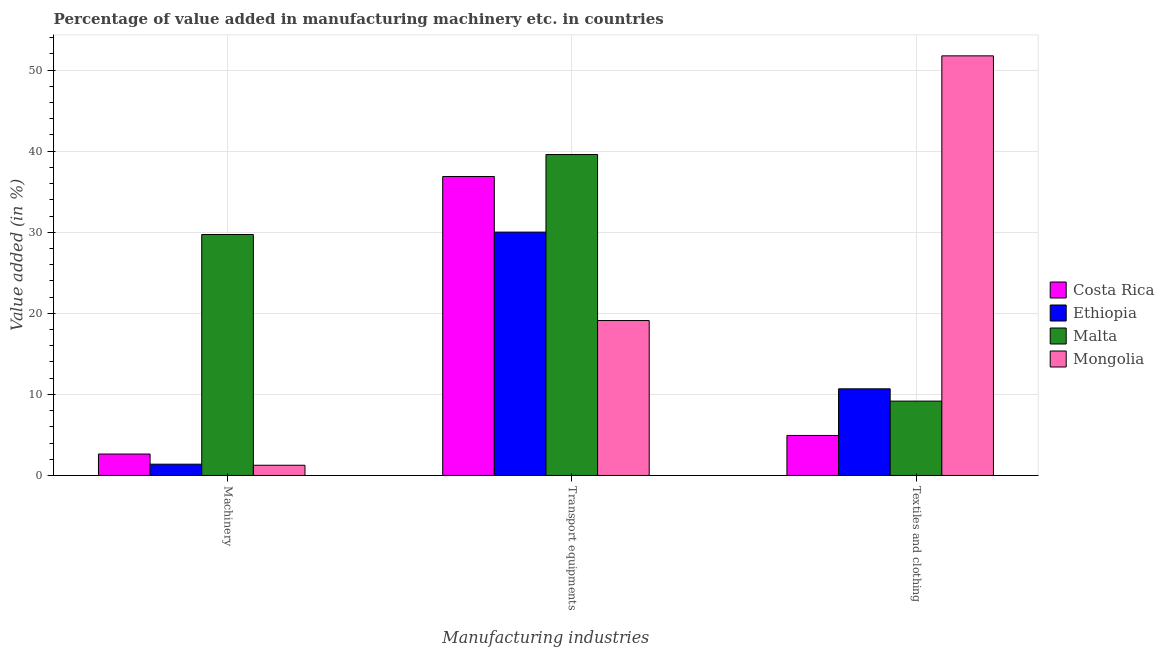Are the number of bars per tick equal to the number of legend labels?
Give a very brief answer. Yes. How many bars are there on the 1st tick from the left?
Your answer should be compact. 4. What is the label of the 3rd group of bars from the left?
Ensure brevity in your answer.  Textiles and clothing. What is the value added in manufacturing transport equipments in Costa Rica?
Your response must be concise. 36.88. Across all countries, what is the maximum value added in manufacturing textile and clothing?
Ensure brevity in your answer.  51.76. Across all countries, what is the minimum value added in manufacturing textile and clothing?
Your answer should be compact. 4.93. In which country was the value added in manufacturing textile and clothing maximum?
Your answer should be compact. Mongolia. In which country was the value added in manufacturing textile and clothing minimum?
Your answer should be very brief. Costa Rica. What is the total value added in manufacturing machinery in the graph?
Ensure brevity in your answer.  35.01. What is the difference between the value added in manufacturing machinery in Mongolia and that in Costa Rica?
Provide a short and direct response. -1.38. What is the difference between the value added in manufacturing textile and clothing in Costa Rica and the value added in manufacturing transport equipments in Malta?
Keep it short and to the point. -34.66. What is the average value added in manufacturing textile and clothing per country?
Ensure brevity in your answer.  19.14. What is the difference between the value added in manufacturing machinery and value added in manufacturing textile and clothing in Malta?
Provide a succinct answer. 20.55. In how many countries, is the value added in manufacturing textile and clothing greater than 50 %?
Give a very brief answer. 1. What is the ratio of the value added in manufacturing transport equipments in Malta to that in Costa Rica?
Your response must be concise. 1.07. Is the difference between the value added in manufacturing machinery in Costa Rica and Mongolia greater than the difference between the value added in manufacturing textile and clothing in Costa Rica and Mongolia?
Give a very brief answer. Yes. What is the difference between the highest and the second highest value added in manufacturing transport equipments?
Offer a very short reply. 2.71. What is the difference between the highest and the lowest value added in manufacturing machinery?
Ensure brevity in your answer.  28.47. In how many countries, is the value added in manufacturing machinery greater than the average value added in manufacturing machinery taken over all countries?
Your answer should be very brief. 1. What does the 4th bar from the right in Textiles and clothing represents?
Provide a short and direct response. Costa Rica. Is it the case that in every country, the sum of the value added in manufacturing machinery and value added in manufacturing transport equipments is greater than the value added in manufacturing textile and clothing?
Your answer should be compact. No. How many countries are there in the graph?
Your answer should be very brief. 4. What is the difference between two consecutive major ticks on the Y-axis?
Make the answer very short. 10. Are the values on the major ticks of Y-axis written in scientific E-notation?
Offer a very short reply. No. Does the graph contain any zero values?
Your answer should be compact. No. Where does the legend appear in the graph?
Provide a succinct answer. Center right. How are the legend labels stacked?
Offer a very short reply. Vertical. What is the title of the graph?
Give a very brief answer. Percentage of value added in manufacturing machinery etc. in countries. What is the label or title of the X-axis?
Your answer should be very brief. Manufacturing industries. What is the label or title of the Y-axis?
Provide a succinct answer. Value added (in %). What is the Value added (in %) in Costa Rica in Machinery?
Ensure brevity in your answer.  2.64. What is the Value added (in %) in Ethiopia in Machinery?
Your answer should be very brief. 1.39. What is the Value added (in %) of Malta in Machinery?
Offer a terse response. 29.72. What is the Value added (in %) in Mongolia in Machinery?
Make the answer very short. 1.26. What is the Value added (in %) of Costa Rica in Transport equipments?
Make the answer very short. 36.88. What is the Value added (in %) of Ethiopia in Transport equipments?
Ensure brevity in your answer.  30.02. What is the Value added (in %) of Malta in Transport equipments?
Make the answer very short. 39.59. What is the Value added (in %) in Mongolia in Transport equipments?
Ensure brevity in your answer.  19.11. What is the Value added (in %) of Costa Rica in Textiles and clothing?
Make the answer very short. 4.93. What is the Value added (in %) in Ethiopia in Textiles and clothing?
Offer a terse response. 10.69. What is the Value added (in %) in Malta in Textiles and clothing?
Your answer should be compact. 9.17. What is the Value added (in %) of Mongolia in Textiles and clothing?
Give a very brief answer. 51.76. Across all Manufacturing industries, what is the maximum Value added (in %) in Costa Rica?
Keep it short and to the point. 36.88. Across all Manufacturing industries, what is the maximum Value added (in %) of Ethiopia?
Your answer should be very brief. 30.02. Across all Manufacturing industries, what is the maximum Value added (in %) of Malta?
Provide a succinct answer. 39.59. Across all Manufacturing industries, what is the maximum Value added (in %) of Mongolia?
Keep it short and to the point. 51.76. Across all Manufacturing industries, what is the minimum Value added (in %) in Costa Rica?
Give a very brief answer. 2.64. Across all Manufacturing industries, what is the minimum Value added (in %) in Ethiopia?
Offer a terse response. 1.39. Across all Manufacturing industries, what is the minimum Value added (in %) in Malta?
Provide a succinct answer. 9.17. Across all Manufacturing industries, what is the minimum Value added (in %) in Mongolia?
Keep it short and to the point. 1.26. What is the total Value added (in %) in Costa Rica in the graph?
Give a very brief answer. 44.46. What is the total Value added (in %) in Ethiopia in the graph?
Give a very brief answer. 42.1. What is the total Value added (in %) in Malta in the graph?
Your response must be concise. 78.49. What is the total Value added (in %) in Mongolia in the graph?
Offer a terse response. 72.13. What is the difference between the Value added (in %) in Costa Rica in Machinery and that in Transport equipments?
Give a very brief answer. -34.24. What is the difference between the Value added (in %) of Ethiopia in Machinery and that in Transport equipments?
Ensure brevity in your answer.  -28.63. What is the difference between the Value added (in %) in Malta in Machinery and that in Transport equipments?
Make the answer very short. -9.87. What is the difference between the Value added (in %) of Mongolia in Machinery and that in Transport equipments?
Your response must be concise. -17.85. What is the difference between the Value added (in %) of Costa Rica in Machinery and that in Textiles and clothing?
Your answer should be compact. -2.29. What is the difference between the Value added (in %) in Ethiopia in Machinery and that in Textiles and clothing?
Your answer should be very brief. -9.3. What is the difference between the Value added (in %) of Malta in Machinery and that in Textiles and clothing?
Offer a terse response. 20.55. What is the difference between the Value added (in %) in Mongolia in Machinery and that in Textiles and clothing?
Your answer should be compact. -50.51. What is the difference between the Value added (in %) in Costa Rica in Transport equipments and that in Textiles and clothing?
Ensure brevity in your answer.  31.95. What is the difference between the Value added (in %) of Ethiopia in Transport equipments and that in Textiles and clothing?
Offer a very short reply. 19.33. What is the difference between the Value added (in %) in Malta in Transport equipments and that in Textiles and clothing?
Your answer should be compact. 30.42. What is the difference between the Value added (in %) of Mongolia in Transport equipments and that in Textiles and clothing?
Provide a short and direct response. -32.66. What is the difference between the Value added (in %) of Costa Rica in Machinery and the Value added (in %) of Ethiopia in Transport equipments?
Provide a succinct answer. -27.38. What is the difference between the Value added (in %) of Costa Rica in Machinery and the Value added (in %) of Malta in Transport equipments?
Your answer should be very brief. -36.95. What is the difference between the Value added (in %) in Costa Rica in Machinery and the Value added (in %) in Mongolia in Transport equipments?
Your answer should be very brief. -16.47. What is the difference between the Value added (in %) in Ethiopia in Machinery and the Value added (in %) in Malta in Transport equipments?
Offer a very short reply. -38.2. What is the difference between the Value added (in %) in Ethiopia in Machinery and the Value added (in %) in Mongolia in Transport equipments?
Provide a succinct answer. -17.72. What is the difference between the Value added (in %) in Malta in Machinery and the Value added (in %) in Mongolia in Transport equipments?
Keep it short and to the point. 10.62. What is the difference between the Value added (in %) in Costa Rica in Machinery and the Value added (in %) in Ethiopia in Textiles and clothing?
Your response must be concise. -8.05. What is the difference between the Value added (in %) in Costa Rica in Machinery and the Value added (in %) in Malta in Textiles and clothing?
Your response must be concise. -6.53. What is the difference between the Value added (in %) in Costa Rica in Machinery and the Value added (in %) in Mongolia in Textiles and clothing?
Make the answer very short. -49.12. What is the difference between the Value added (in %) in Ethiopia in Machinery and the Value added (in %) in Malta in Textiles and clothing?
Your response must be concise. -7.78. What is the difference between the Value added (in %) of Ethiopia in Machinery and the Value added (in %) of Mongolia in Textiles and clothing?
Provide a succinct answer. -50.37. What is the difference between the Value added (in %) in Malta in Machinery and the Value added (in %) in Mongolia in Textiles and clothing?
Your answer should be compact. -22.04. What is the difference between the Value added (in %) in Costa Rica in Transport equipments and the Value added (in %) in Ethiopia in Textiles and clothing?
Give a very brief answer. 26.2. What is the difference between the Value added (in %) in Costa Rica in Transport equipments and the Value added (in %) in Malta in Textiles and clothing?
Your answer should be very brief. 27.71. What is the difference between the Value added (in %) of Costa Rica in Transport equipments and the Value added (in %) of Mongolia in Textiles and clothing?
Provide a short and direct response. -14.88. What is the difference between the Value added (in %) in Ethiopia in Transport equipments and the Value added (in %) in Malta in Textiles and clothing?
Your answer should be compact. 20.85. What is the difference between the Value added (in %) of Ethiopia in Transport equipments and the Value added (in %) of Mongolia in Textiles and clothing?
Your response must be concise. -21.74. What is the difference between the Value added (in %) of Malta in Transport equipments and the Value added (in %) of Mongolia in Textiles and clothing?
Offer a very short reply. -12.17. What is the average Value added (in %) of Costa Rica per Manufacturing industries?
Give a very brief answer. 14.82. What is the average Value added (in %) in Ethiopia per Manufacturing industries?
Your answer should be compact. 14.03. What is the average Value added (in %) of Malta per Manufacturing industries?
Your answer should be very brief. 26.16. What is the average Value added (in %) of Mongolia per Manufacturing industries?
Keep it short and to the point. 24.04. What is the difference between the Value added (in %) of Costa Rica and Value added (in %) of Ethiopia in Machinery?
Make the answer very short. 1.25. What is the difference between the Value added (in %) of Costa Rica and Value added (in %) of Malta in Machinery?
Offer a very short reply. -27.08. What is the difference between the Value added (in %) in Costa Rica and Value added (in %) in Mongolia in Machinery?
Provide a short and direct response. 1.38. What is the difference between the Value added (in %) of Ethiopia and Value added (in %) of Malta in Machinery?
Provide a short and direct response. -28.33. What is the difference between the Value added (in %) of Ethiopia and Value added (in %) of Mongolia in Machinery?
Provide a succinct answer. 0.13. What is the difference between the Value added (in %) of Malta and Value added (in %) of Mongolia in Machinery?
Offer a very short reply. 28.47. What is the difference between the Value added (in %) of Costa Rica and Value added (in %) of Ethiopia in Transport equipments?
Give a very brief answer. 6.86. What is the difference between the Value added (in %) of Costa Rica and Value added (in %) of Malta in Transport equipments?
Provide a short and direct response. -2.71. What is the difference between the Value added (in %) in Costa Rica and Value added (in %) in Mongolia in Transport equipments?
Provide a succinct answer. 17.77. What is the difference between the Value added (in %) of Ethiopia and Value added (in %) of Malta in Transport equipments?
Offer a very short reply. -9.57. What is the difference between the Value added (in %) in Ethiopia and Value added (in %) in Mongolia in Transport equipments?
Ensure brevity in your answer.  10.91. What is the difference between the Value added (in %) in Malta and Value added (in %) in Mongolia in Transport equipments?
Ensure brevity in your answer.  20.48. What is the difference between the Value added (in %) of Costa Rica and Value added (in %) of Ethiopia in Textiles and clothing?
Keep it short and to the point. -5.75. What is the difference between the Value added (in %) of Costa Rica and Value added (in %) of Malta in Textiles and clothing?
Ensure brevity in your answer.  -4.24. What is the difference between the Value added (in %) in Costa Rica and Value added (in %) in Mongolia in Textiles and clothing?
Your answer should be compact. -46.83. What is the difference between the Value added (in %) in Ethiopia and Value added (in %) in Malta in Textiles and clothing?
Ensure brevity in your answer.  1.51. What is the difference between the Value added (in %) in Ethiopia and Value added (in %) in Mongolia in Textiles and clothing?
Your answer should be compact. -41.08. What is the difference between the Value added (in %) in Malta and Value added (in %) in Mongolia in Textiles and clothing?
Ensure brevity in your answer.  -42.59. What is the ratio of the Value added (in %) of Costa Rica in Machinery to that in Transport equipments?
Ensure brevity in your answer.  0.07. What is the ratio of the Value added (in %) of Ethiopia in Machinery to that in Transport equipments?
Provide a succinct answer. 0.05. What is the ratio of the Value added (in %) in Malta in Machinery to that in Transport equipments?
Give a very brief answer. 0.75. What is the ratio of the Value added (in %) of Mongolia in Machinery to that in Transport equipments?
Your response must be concise. 0.07. What is the ratio of the Value added (in %) in Costa Rica in Machinery to that in Textiles and clothing?
Offer a terse response. 0.54. What is the ratio of the Value added (in %) of Ethiopia in Machinery to that in Textiles and clothing?
Give a very brief answer. 0.13. What is the ratio of the Value added (in %) of Malta in Machinery to that in Textiles and clothing?
Your response must be concise. 3.24. What is the ratio of the Value added (in %) of Mongolia in Machinery to that in Textiles and clothing?
Provide a short and direct response. 0.02. What is the ratio of the Value added (in %) of Costa Rica in Transport equipments to that in Textiles and clothing?
Your response must be concise. 7.47. What is the ratio of the Value added (in %) of Ethiopia in Transport equipments to that in Textiles and clothing?
Offer a terse response. 2.81. What is the ratio of the Value added (in %) of Malta in Transport equipments to that in Textiles and clothing?
Give a very brief answer. 4.32. What is the ratio of the Value added (in %) of Mongolia in Transport equipments to that in Textiles and clothing?
Offer a terse response. 0.37. What is the difference between the highest and the second highest Value added (in %) in Costa Rica?
Your answer should be very brief. 31.95. What is the difference between the highest and the second highest Value added (in %) in Ethiopia?
Your response must be concise. 19.33. What is the difference between the highest and the second highest Value added (in %) of Malta?
Provide a short and direct response. 9.87. What is the difference between the highest and the second highest Value added (in %) of Mongolia?
Provide a short and direct response. 32.66. What is the difference between the highest and the lowest Value added (in %) of Costa Rica?
Make the answer very short. 34.24. What is the difference between the highest and the lowest Value added (in %) in Ethiopia?
Keep it short and to the point. 28.63. What is the difference between the highest and the lowest Value added (in %) in Malta?
Provide a short and direct response. 30.42. What is the difference between the highest and the lowest Value added (in %) in Mongolia?
Offer a terse response. 50.51. 